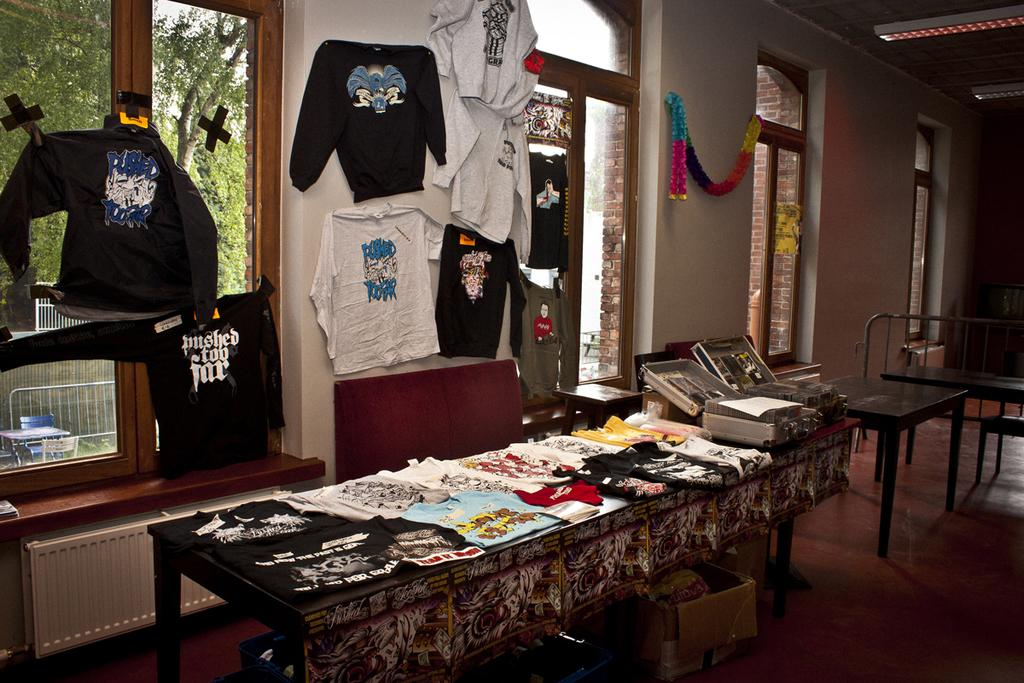What type of establishment is depicted in the image? The image is of a store. What items can be seen on the table in the store? There are different types of clothes on a table, as well as boxes. How are the clothes displayed on the wall? Clothes are hanging on the wall. What is the location of the cardboard box in the image? A cardboard box is on the floor. How many cherries are on the table in the image? There are no cherries present in the image. What is the size of the cent on the floor in the image? There is no cent present in the image. 